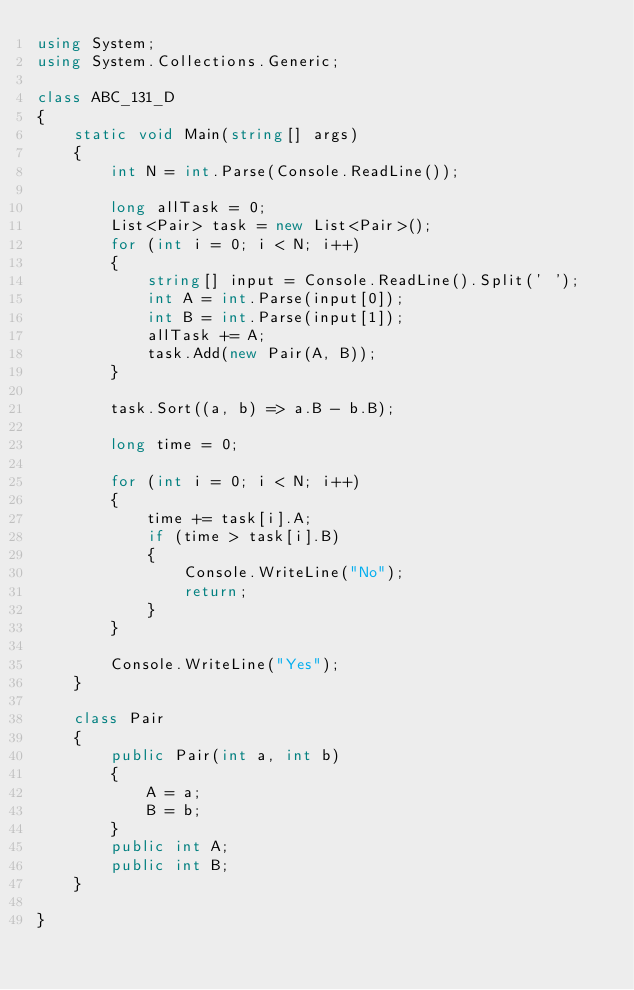Convert code to text. <code><loc_0><loc_0><loc_500><loc_500><_C#_>using System;
using System.Collections.Generic;

class ABC_131_D
{
    static void Main(string[] args)
    {
        int N = int.Parse(Console.ReadLine());

        long allTask = 0;
        List<Pair> task = new List<Pair>();
        for (int i = 0; i < N; i++)
        {
            string[] input = Console.ReadLine().Split(' ');
            int A = int.Parse(input[0]);
            int B = int.Parse(input[1]);
            allTask += A;
            task.Add(new Pair(A, B));
        }

        task.Sort((a, b) => a.B - b.B);

        long time = 0;

        for (int i = 0; i < N; i++)
        {
            time += task[i].A;
            if (time > task[i].B)
            {
                Console.WriteLine("No");
                return;
            }
        }

        Console.WriteLine("Yes");
    }

    class Pair
    {
        public Pair(int a, int b)
        {
            A = a;
            B = b;
        }
        public int A;
        public int B;
    }

}
</code> 